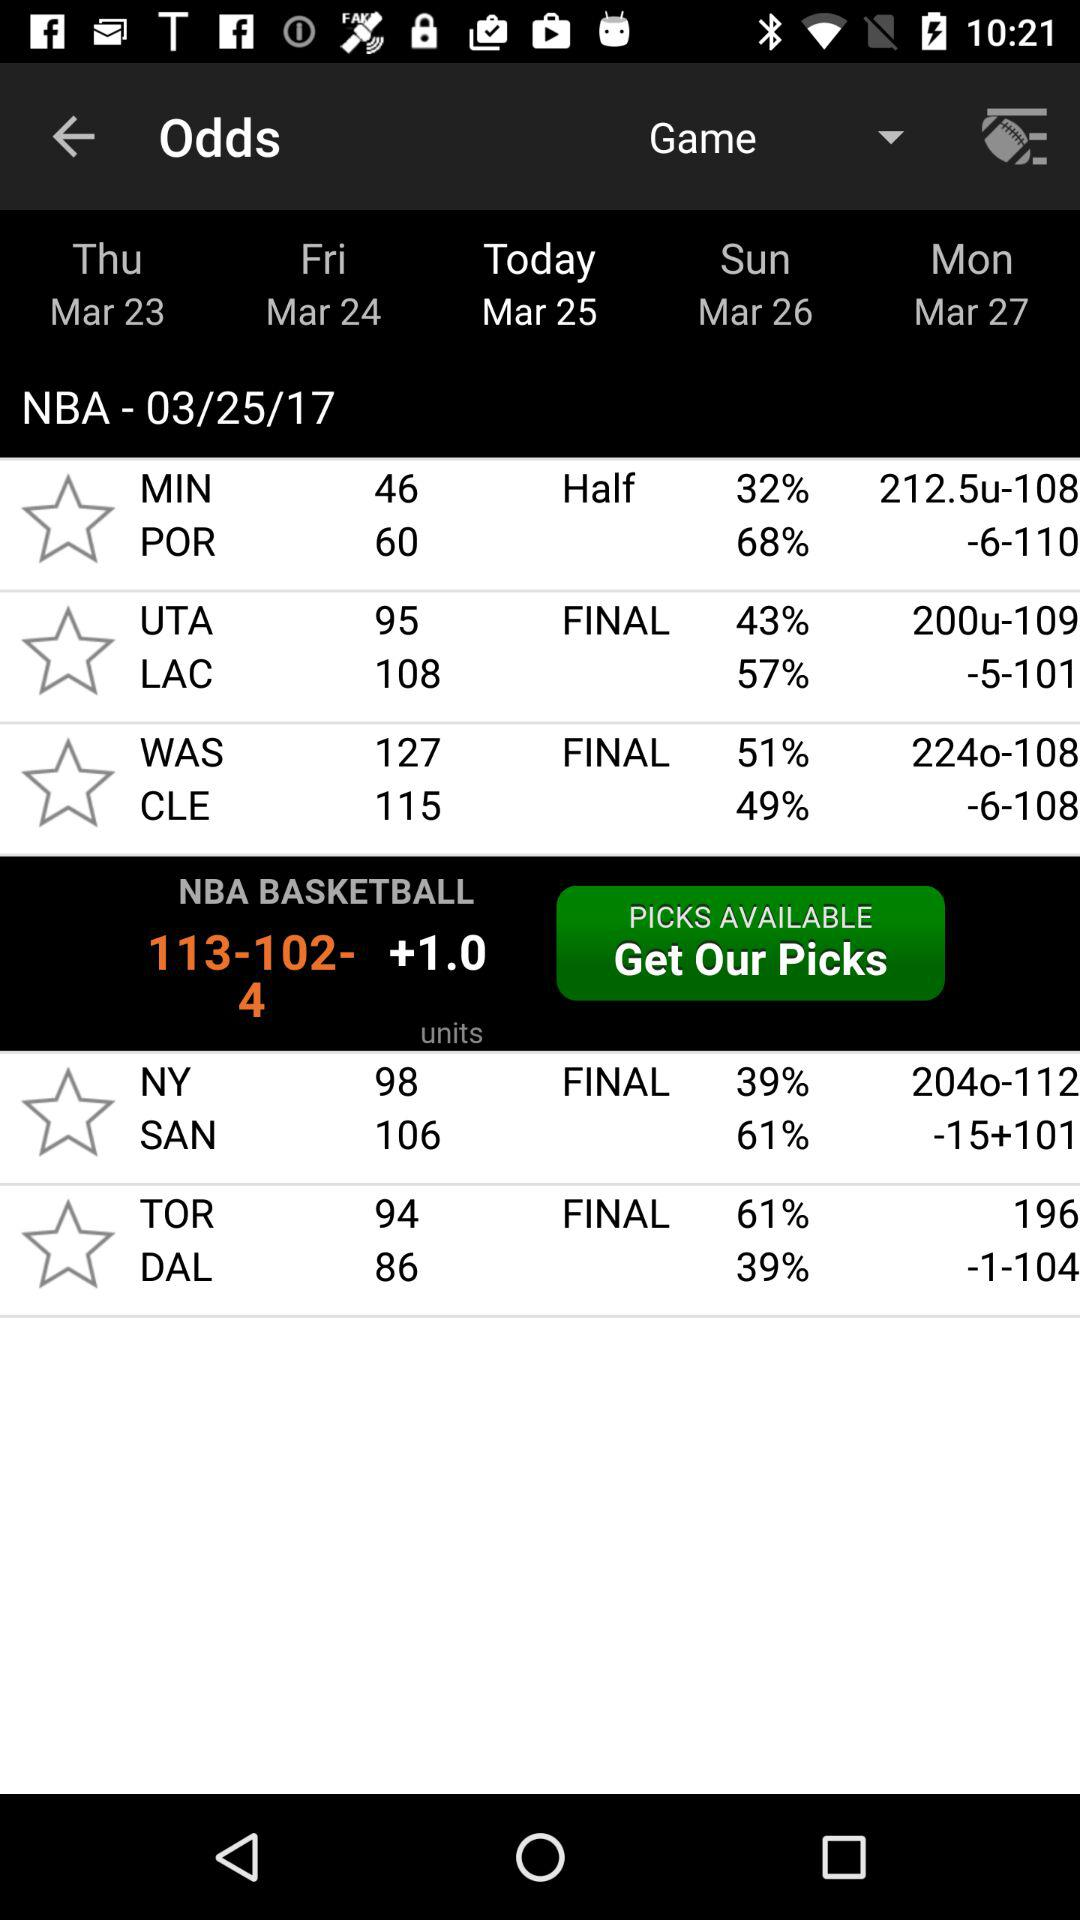What is the date today? The date today is March 25. 